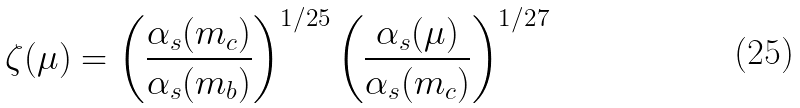Convert formula to latex. <formula><loc_0><loc_0><loc_500><loc_500>\zeta ( \mu ) = \left ( \frac { \alpha _ { s } ( m _ { c } ) } { \alpha _ { s } ( m _ { b } ) } \right ) ^ { 1 / 2 5 } \left ( \frac { \alpha _ { s } ( \mu ) } { \alpha _ { s } ( m _ { c } ) } \right ) ^ { 1 / 2 7 }</formula> 